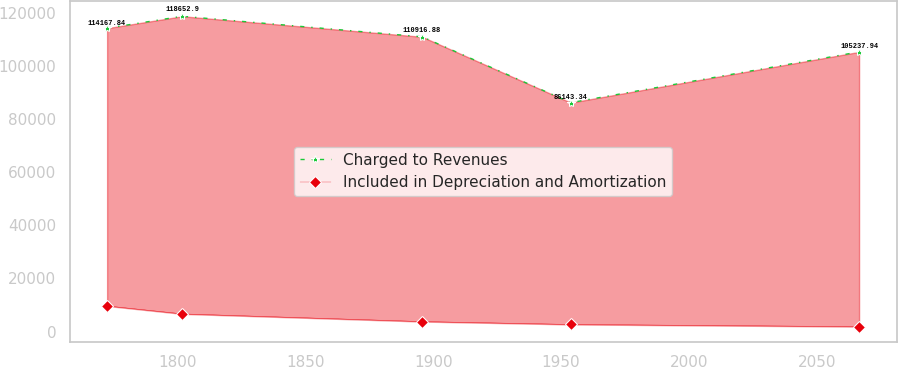<chart> <loc_0><loc_0><loc_500><loc_500><line_chart><ecel><fcel>Charged to Revenues<fcel>Included in Depreciation and Amortization<nl><fcel>1772.43<fcel>114168<fcel>9636.16<nl><fcel>1801.84<fcel>118653<fcel>6658.51<nl><fcel>1895.64<fcel>110917<fcel>3766.85<nl><fcel>1953.76<fcel>86143.3<fcel>2685.95<nl><fcel>2066.55<fcel>105238<fcel>1864.67<nl></chart> 